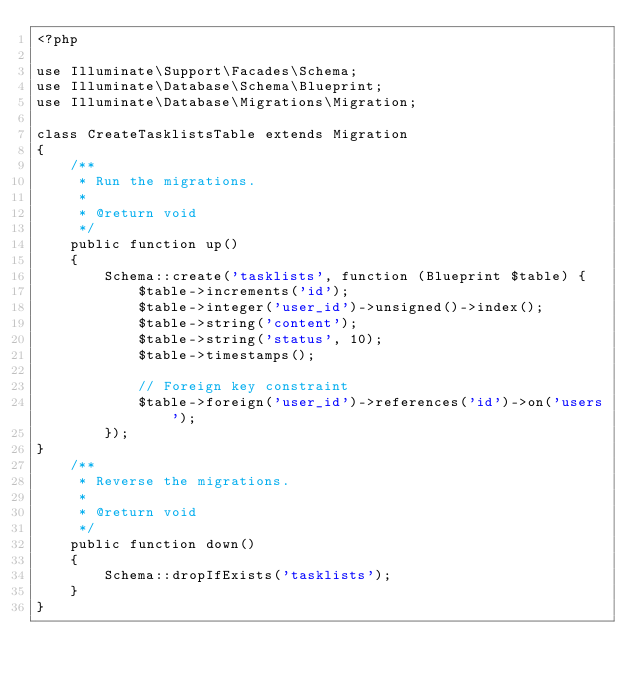<code> <loc_0><loc_0><loc_500><loc_500><_PHP_><?php

use Illuminate\Support\Facades\Schema;
use Illuminate\Database\Schema\Blueprint;
use Illuminate\Database\Migrations\Migration;

class CreateTasklistsTable extends Migration
{
    /**
     * Run the migrations.
     *
     * @return void
     */
    public function up()
    {
        Schema::create('tasklists', function (Blueprint $table) {
            $table->increments('id');
            $table->integer('user_id')->unsigned()->index();
            $table->string('content');
            $table->string('status', 10);
            $table->timestamps();

            // Foreign key constraint
            $table->foreign('user_id')->references('id')->on('users');
        });
}
    /**
     * Reverse the migrations.
     *
     * @return void
     */
    public function down()
    {
        Schema::dropIfExists('tasklists');
    }
}
</code> 